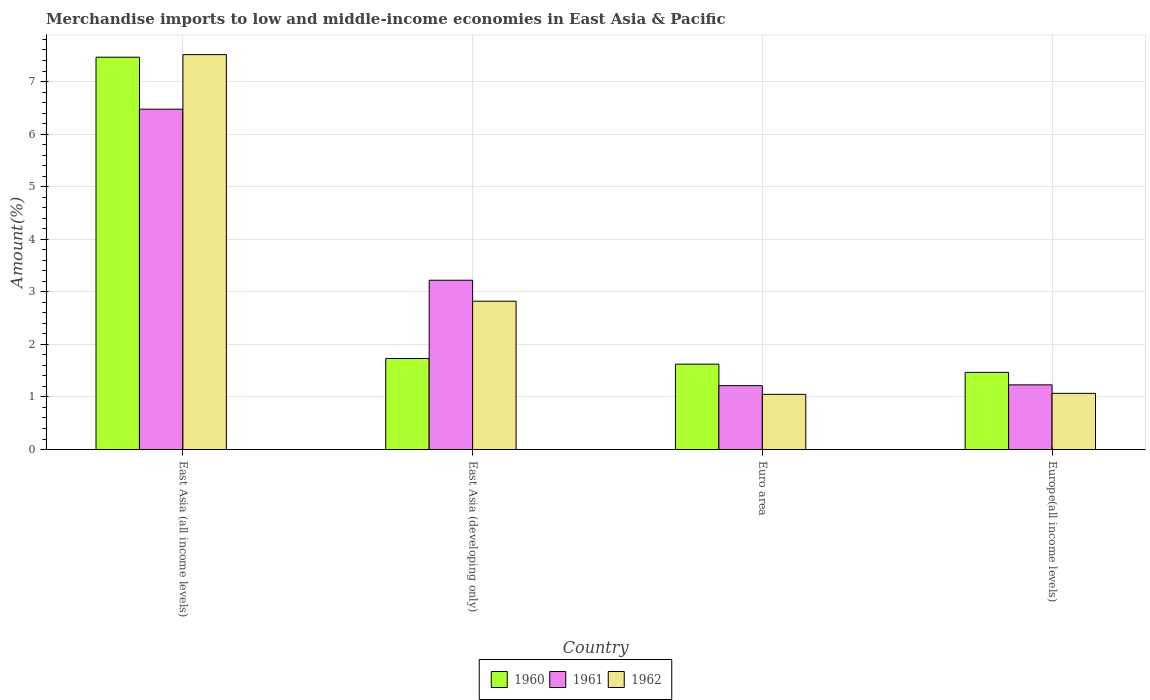Are the number of bars on each tick of the X-axis equal?
Your answer should be compact. Yes. How many bars are there on the 2nd tick from the left?
Your answer should be compact. 3. How many bars are there on the 2nd tick from the right?
Keep it short and to the point. 3. What is the label of the 1st group of bars from the left?
Offer a terse response. East Asia (all income levels). In how many cases, is the number of bars for a given country not equal to the number of legend labels?
Provide a succinct answer. 0. What is the percentage of amount earned from merchandise imports in 1961 in Europe(all income levels)?
Keep it short and to the point. 1.23. Across all countries, what is the maximum percentage of amount earned from merchandise imports in 1962?
Your answer should be compact. 7.51. Across all countries, what is the minimum percentage of amount earned from merchandise imports in 1960?
Offer a very short reply. 1.47. In which country was the percentage of amount earned from merchandise imports in 1962 maximum?
Make the answer very short. East Asia (all income levels). In which country was the percentage of amount earned from merchandise imports in 1961 minimum?
Provide a succinct answer. Euro area. What is the total percentage of amount earned from merchandise imports in 1961 in the graph?
Your answer should be very brief. 12.14. What is the difference between the percentage of amount earned from merchandise imports in 1961 in East Asia (all income levels) and that in East Asia (developing only)?
Provide a succinct answer. 3.25. What is the difference between the percentage of amount earned from merchandise imports in 1962 in East Asia (all income levels) and the percentage of amount earned from merchandise imports in 1960 in East Asia (developing only)?
Your response must be concise. 5.78. What is the average percentage of amount earned from merchandise imports in 1960 per country?
Offer a terse response. 3.07. What is the difference between the percentage of amount earned from merchandise imports of/in 1962 and percentage of amount earned from merchandise imports of/in 1960 in East Asia (developing only)?
Your answer should be very brief. 1.09. What is the ratio of the percentage of amount earned from merchandise imports in 1960 in East Asia (all income levels) to that in East Asia (developing only)?
Offer a very short reply. 4.31. Is the percentage of amount earned from merchandise imports in 1962 in East Asia (developing only) less than that in Europe(all income levels)?
Give a very brief answer. No. What is the difference between the highest and the second highest percentage of amount earned from merchandise imports in 1960?
Your answer should be very brief. 0.11. What is the difference between the highest and the lowest percentage of amount earned from merchandise imports in 1961?
Your answer should be very brief. 5.26. What does the 2nd bar from the left in Europe(all income levels) represents?
Provide a succinct answer. 1961. Are all the bars in the graph horizontal?
Offer a terse response. No. How many countries are there in the graph?
Give a very brief answer. 4. Are the values on the major ticks of Y-axis written in scientific E-notation?
Your response must be concise. No. Does the graph contain grids?
Offer a terse response. Yes. Where does the legend appear in the graph?
Provide a short and direct response. Bottom center. How many legend labels are there?
Ensure brevity in your answer.  3. What is the title of the graph?
Offer a very short reply. Merchandise imports to low and middle-income economies in East Asia & Pacific. Does "1967" appear as one of the legend labels in the graph?
Offer a terse response. No. What is the label or title of the Y-axis?
Offer a terse response. Amount(%). What is the Amount(%) of 1960 in East Asia (all income levels)?
Your response must be concise. 7.46. What is the Amount(%) in 1961 in East Asia (all income levels)?
Offer a terse response. 6.47. What is the Amount(%) of 1962 in East Asia (all income levels)?
Your response must be concise. 7.51. What is the Amount(%) in 1960 in East Asia (developing only)?
Give a very brief answer. 1.73. What is the Amount(%) in 1961 in East Asia (developing only)?
Offer a very short reply. 3.22. What is the Amount(%) of 1962 in East Asia (developing only)?
Make the answer very short. 2.82. What is the Amount(%) of 1960 in Euro area?
Your response must be concise. 1.62. What is the Amount(%) in 1961 in Euro area?
Make the answer very short. 1.21. What is the Amount(%) in 1962 in Euro area?
Keep it short and to the point. 1.05. What is the Amount(%) in 1960 in Europe(all income levels)?
Provide a succinct answer. 1.47. What is the Amount(%) of 1961 in Europe(all income levels)?
Your answer should be very brief. 1.23. What is the Amount(%) in 1962 in Europe(all income levels)?
Offer a very short reply. 1.07. Across all countries, what is the maximum Amount(%) in 1960?
Provide a succinct answer. 7.46. Across all countries, what is the maximum Amount(%) of 1961?
Keep it short and to the point. 6.47. Across all countries, what is the maximum Amount(%) in 1962?
Keep it short and to the point. 7.51. Across all countries, what is the minimum Amount(%) of 1960?
Give a very brief answer. 1.47. Across all countries, what is the minimum Amount(%) of 1961?
Provide a succinct answer. 1.21. Across all countries, what is the minimum Amount(%) in 1962?
Keep it short and to the point. 1.05. What is the total Amount(%) of 1960 in the graph?
Offer a terse response. 12.29. What is the total Amount(%) in 1961 in the graph?
Give a very brief answer. 12.14. What is the total Amount(%) of 1962 in the graph?
Your answer should be very brief. 12.45. What is the difference between the Amount(%) of 1960 in East Asia (all income levels) and that in East Asia (developing only)?
Offer a terse response. 5.73. What is the difference between the Amount(%) in 1961 in East Asia (all income levels) and that in East Asia (developing only)?
Give a very brief answer. 3.25. What is the difference between the Amount(%) of 1962 in East Asia (all income levels) and that in East Asia (developing only)?
Your response must be concise. 4.69. What is the difference between the Amount(%) in 1960 in East Asia (all income levels) and that in Euro area?
Offer a terse response. 5.84. What is the difference between the Amount(%) of 1961 in East Asia (all income levels) and that in Euro area?
Make the answer very short. 5.26. What is the difference between the Amount(%) of 1962 in East Asia (all income levels) and that in Euro area?
Your response must be concise. 6.46. What is the difference between the Amount(%) in 1960 in East Asia (all income levels) and that in Europe(all income levels)?
Provide a succinct answer. 6. What is the difference between the Amount(%) of 1961 in East Asia (all income levels) and that in Europe(all income levels)?
Offer a very short reply. 5.24. What is the difference between the Amount(%) in 1962 in East Asia (all income levels) and that in Europe(all income levels)?
Your answer should be very brief. 6.44. What is the difference between the Amount(%) in 1960 in East Asia (developing only) and that in Euro area?
Ensure brevity in your answer.  0.11. What is the difference between the Amount(%) of 1961 in East Asia (developing only) and that in Euro area?
Keep it short and to the point. 2.01. What is the difference between the Amount(%) in 1962 in East Asia (developing only) and that in Euro area?
Ensure brevity in your answer.  1.77. What is the difference between the Amount(%) of 1960 in East Asia (developing only) and that in Europe(all income levels)?
Keep it short and to the point. 0.26. What is the difference between the Amount(%) of 1961 in East Asia (developing only) and that in Europe(all income levels)?
Ensure brevity in your answer.  1.99. What is the difference between the Amount(%) of 1962 in East Asia (developing only) and that in Europe(all income levels)?
Ensure brevity in your answer.  1.75. What is the difference between the Amount(%) in 1960 in Euro area and that in Europe(all income levels)?
Your answer should be compact. 0.16. What is the difference between the Amount(%) in 1961 in Euro area and that in Europe(all income levels)?
Provide a succinct answer. -0.01. What is the difference between the Amount(%) of 1962 in Euro area and that in Europe(all income levels)?
Ensure brevity in your answer.  -0.02. What is the difference between the Amount(%) of 1960 in East Asia (all income levels) and the Amount(%) of 1961 in East Asia (developing only)?
Your answer should be very brief. 4.24. What is the difference between the Amount(%) in 1960 in East Asia (all income levels) and the Amount(%) in 1962 in East Asia (developing only)?
Offer a very short reply. 4.64. What is the difference between the Amount(%) in 1961 in East Asia (all income levels) and the Amount(%) in 1962 in East Asia (developing only)?
Keep it short and to the point. 3.65. What is the difference between the Amount(%) in 1960 in East Asia (all income levels) and the Amount(%) in 1961 in Euro area?
Offer a very short reply. 6.25. What is the difference between the Amount(%) of 1960 in East Asia (all income levels) and the Amount(%) of 1962 in Euro area?
Your answer should be very brief. 6.41. What is the difference between the Amount(%) of 1961 in East Asia (all income levels) and the Amount(%) of 1962 in Euro area?
Ensure brevity in your answer.  5.42. What is the difference between the Amount(%) in 1960 in East Asia (all income levels) and the Amount(%) in 1961 in Europe(all income levels)?
Your answer should be very brief. 6.23. What is the difference between the Amount(%) of 1960 in East Asia (all income levels) and the Amount(%) of 1962 in Europe(all income levels)?
Make the answer very short. 6.39. What is the difference between the Amount(%) of 1961 in East Asia (all income levels) and the Amount(%) of 1962 in Europe(all income levels)?
Your response must be concise. 5.41. What is the difference between the Amount(%) of 1960 in East Asia (developing only) and the Amount(%) of 1961 in Euro area?
Your answer should be very brief. 0.52. What is the difference between the Amount(%) of 1960 in East Asia (developing only) and the Amount(%) of 1962 in Euro area?
Your response must be concise. 0.68. What is the difference between the Amount(%) in 1961 in East Asia (developing only) and the Amount(%) in 1962 in Euro area?
Ensure brevity in your answer.  2.17. What is the difference between the Amount(%) in 1960 in East Asia (developing only) and the Amount(%) in 1961 in Europe(all income levels)?
Make the answer very short. 0.5. What is the difference between the Amount(%) of 1960 in East Asia (developing only) and the Amount(%) of 1962 in Europe(all income levels)?
Keep it short and to the point. 0.66. What is the difference between the Amount(%) in 1961 in East Asia (developing only) and the Amount(%) in 1962 in Europe(all income levels)?
Keep it short and to the point. 2.15. What is the difference between the Amount(%) in 1960 in Euro area and the Amount(%) in 1961 in Europe(all income levels)?
Offer a very short reply. 0.39. What is the difference between the Amount(%) of 1960 in Euro area and the Amount(%) of 1962 in Europe(all income levels)?
Keep it short and to the point. 0.56. What is the difference between the Amount(%) in 1961 in Euro area and the Amount(%) in 1962 in Europe(all income levels)?
Your response must be concise. 0.15. What is the average Amount(%) of 1960 per country?
Provide a succinct answer. 3.07. What is the average Amount(%) of 1961 per country?
Keep it short and to the point. 3.03. What is the average Amount(%) in 1962 per country?
Offer a very short reply. 3.11. What is the difference between the Amount(%) in 1960 and Amount(%) in 1961 in East Asia (all income levels)?
Your answer should be very brief. 0.99. What is the difference between the Amount(%) in 1960 and Amount(%) in 1962 in East Asia (all income levels)?
Your response must be concise. -0.05. What is the difference between the Amount(%) of 1961 and Amount(%) of 1962 in East Asia (all income levels)?
Keep it short and to the point. -1.04. What is the difference between the Amount(%) in 1960 and Amount(%) in 1961 in East Asia (developing only)?
Provide a short and direct response. -1.49. What is the difference between the Amount(%) of 1960 and Amount(%) of 1962 in East Asia (developing only)?
Provide a succinct answer. -1.09. What is the difference between the Amount(%) of 1961 and Amount(%) of 1962 in East Asia (developing only)?
Provide a short and direct response. 0.4. What is the difference between the Amount(%) of 1960 and Amount(%) of 1961 in Euro area?
Give a very brief answer. 0.41. What is the difference between the Amount(%) in 1960 and Amount(%) in 1962 in Euro area?
Make the answer very short. 0.57. What is the difference between the Amount(%) in 1961 and Amount(%) in 1962 in Euro area?
Provide a succinct answer. 0.17. What is the difference between the Amount(%) of 1960 and Amount(%) of 1961 in Europe(all income levels)?
Provide a succinct answer. 0.24. What is the difference between the Amount(%) in 1960 and Amount(%) in 1962 in Europe(all income levels)?
Your answer should be compact. 0.4. What is the difference between the Amount(%) in 1961 and Amount(%) in 1962 in Europe(all income levels)?
Your answer should be compact. 0.16. What is the ratio of the Amount(%) of 1960 in East Asia (all income levels) to that in East Asia (developing only)?
Your response must be concise. 4.31. What is the ratio of the Amount(%) in 1961 in East Asia (all income levels) to that in East Asia (developing only)?
Provide a succinct answer. 2.01. What is the ratio of the Amount(%) in 1962 in East Asia (all income levels) to that in East Asia (developing only)?
Offer a terse response. 2.66. What is the ratio of the Amount(%) in 1960 in East Asia (all income levels) to that in Euro area?
Keep it short and to the point. 4.59. What is the ratio of the Amount(%) of 1961 in East Asia (all income levels) to that in Euro area?
Offer a terse response. 5.33. What is the ratio of the Amount(%) of 1962 in East Asia (all income levels) to that in Euro area?
Your answer should be very brief. 7.16. What is the ratio of the Amount(%) in 1960 in East Asia (all income levels) to that in Europe(all income levels)?
Offer a terse response. 5.09. What is the ratio of the Amount(%) in 1961 in East Asia (all income levels) to that in Europe(all income levels)?
Provide a short and direct response. 5.26. What is the ratio of the Amount(%) in 1962 in East Asia (all income levels) to that in Europe(all income levels)?
Offer a terse response. 7.03. What is the ratio of the Amount(%) of 1960 in East Asia (developing only) to that in Euro area?
Provide a short and direct response. 1.07. What is the ratio of the Amount(%) in 1961 in East Asia (developing only) to that in Euro area?
Provide a short and direct response. 2.65. What is the ratio of the Amount(%) in 1962 in East Asia (developing only) to that in Euro area?
Give a very brief answer. 2.69. What is the ratio of the Amount(%) in 1960 in East Asia (developing only) to that in Europe(all income levels)?
Your answer should be very brief. 1.18. What is the ratio of the Amount(%) of 1961 in East Asia (developing only) to that in Europe(all income levels)?
Your answer should be compact. 2.62. What is the ratio of the Amount(%) in 1962 in East Asia (developing only) to that in Europe(all income levels)?
Give a very brief answer. 2.64. What is the ratio of the Amount(%) of 1960 in Euro area to that in Europe(all income levels)?
Provide a short and direct response. 1.11. What is the ratio of the Amount(%) in 1961 in Euro area to that in Europe(all income levels)?
Keep it short and to the point. 0.99. What is the ratio of the Amount(%) in 1962 in Euro area to that in Europe(all income levels)?
Make the answer very short. 0.98. What is the difference between the highest and the second highest Amount(%) in 1960?
Provide a short and direct response. 5.73. What is the difference between the highest and the second highest Amount(%) of 1961?
Provide a succinct answer. 3.25. What is the difference between the highest and the second highest Amount(%) in 1962?
Provide a short and direct response. 4.69. What is the difference between the highest and the lowest Amount(%) in 1960?
Keep it short and to the point. 6. What is the difference between the highest and the lowest Amount(%) in 1961?
Keep it short and to the point. 5.26. What is the difference between the highest and the lowest Amount(%) in 1962?
Offer a terse response. 6.46. 